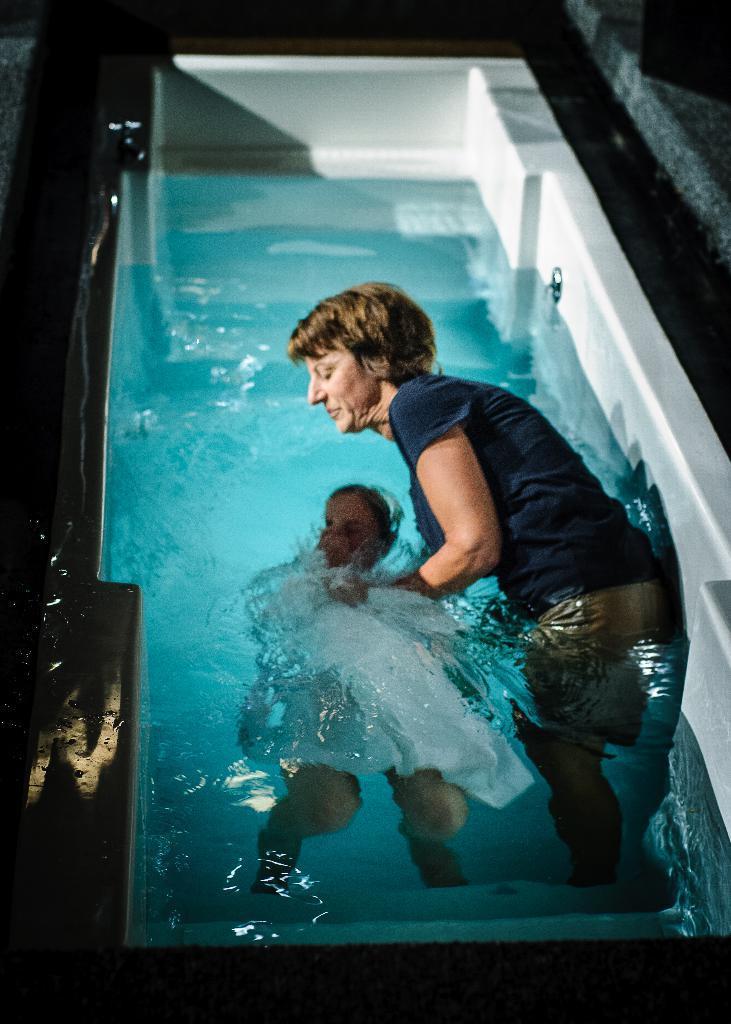How would you summarize this image in a sentence or two? In this image we can see a woman and a child in the swimming pool. 